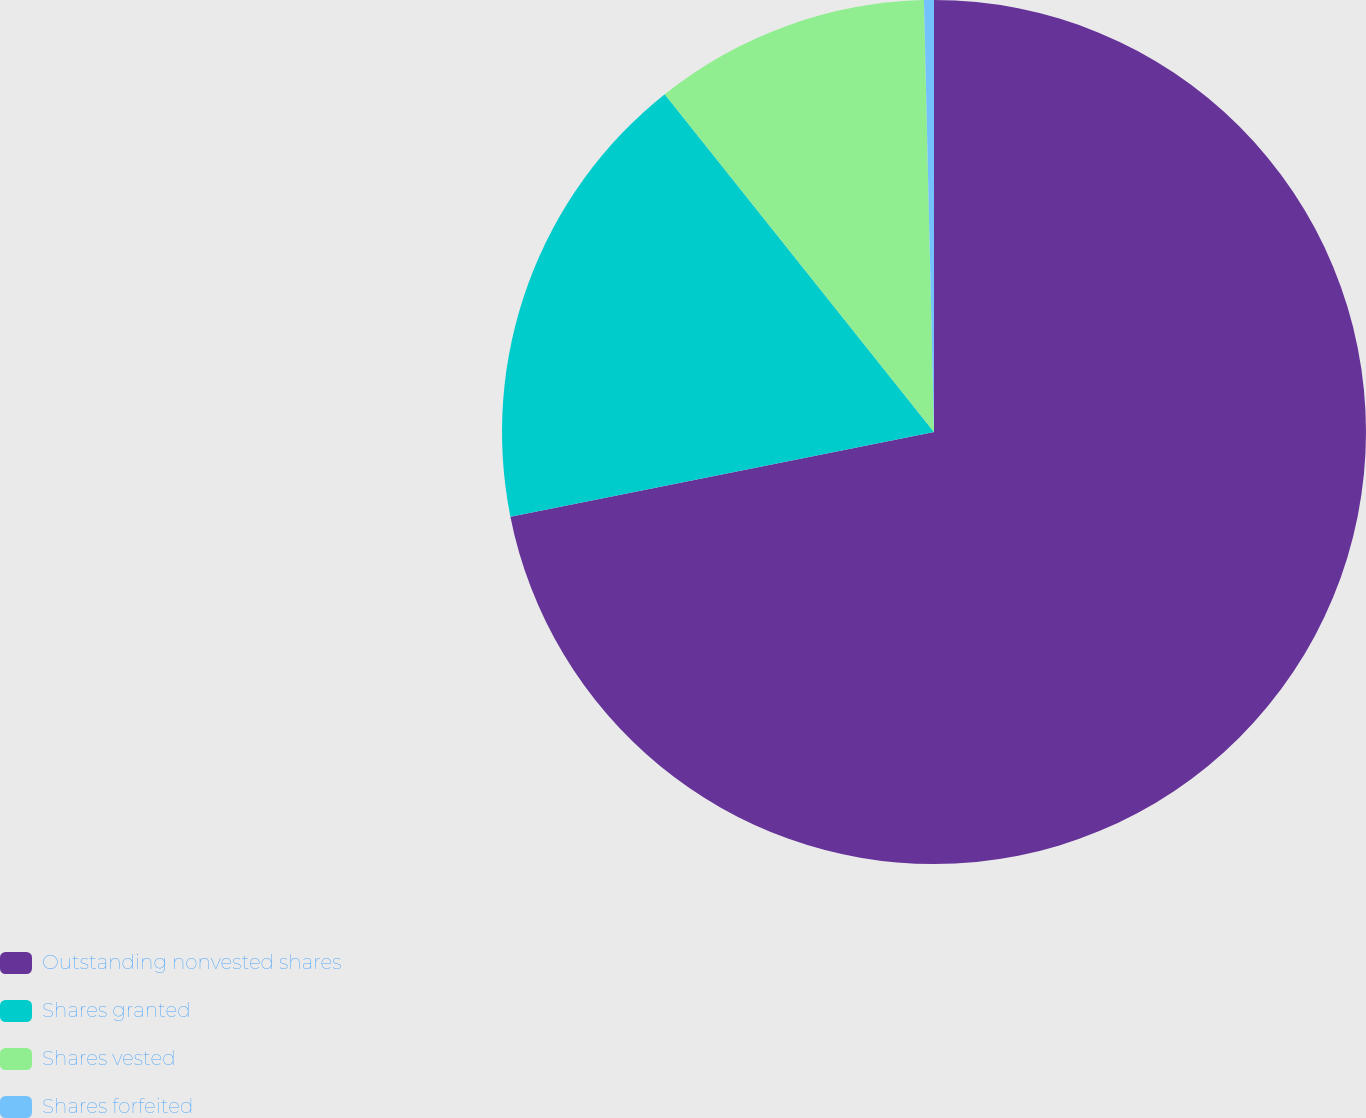Convert chart. <chart><loc_0><loc_0><loc_500><loc_500><pie_chart><fcel>Outstanding nonvested shares<fcel>Shares granted<fcel>Shares vested<fcel>Shares forfeited<nl><fcel>71.86%<fcel>17.43%<fcel>10.34%<fcel>0.37%<nl></chart> 